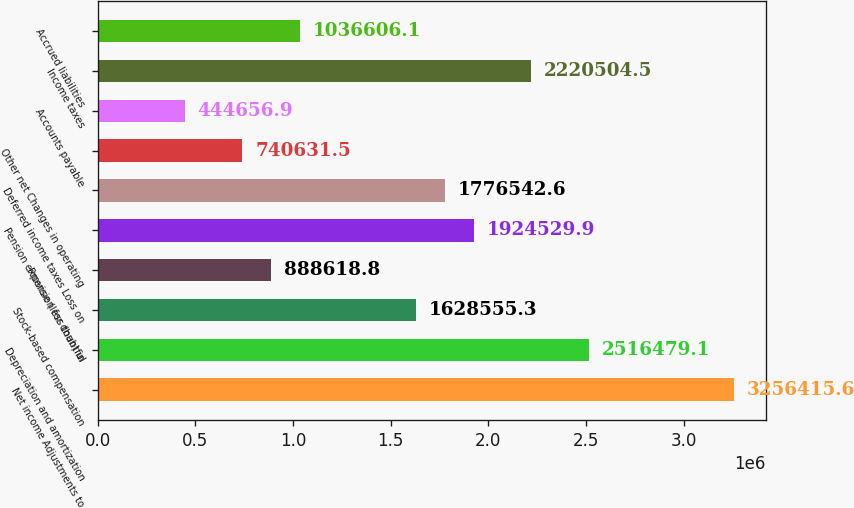Convert chart. <chart><loc_0><loc_0><loc_500><loc_500><bar_chart><fcel>Net income Adjustments to<fcel>Depreciation and amortization<fcel>Stock-based compensation<fcel>Provision for doubtful<fcel>Pension expense (less than) in<fcel>Deferred income taxes Loss on<fcel>Other net Changes in operating<fcel>Accounts payable<fcel>Income taxes<fcel>Accrued liabilities<nl><fcel>3.25642e+06<fcel>2.51648e+06<fcel>1.62856e+06<fcel>888619<fcel>1.92453e+06<fcel>1.77654e+06<fcel>740632<fcel>444657<fcel>2.2205e+06<fcel>1.03661e+06<nl></chart> 